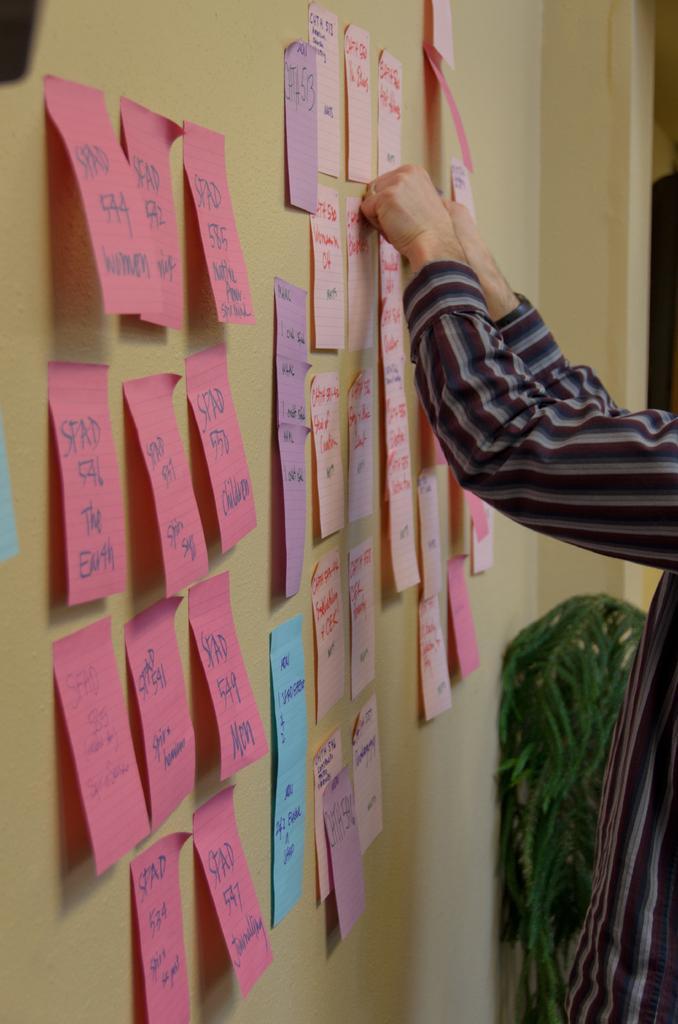Could you give a brief overview of what you see in this image? In this picture there are few papers which has something written on it is attached to the wall in the left corner and there is a person standing in the right corner. 